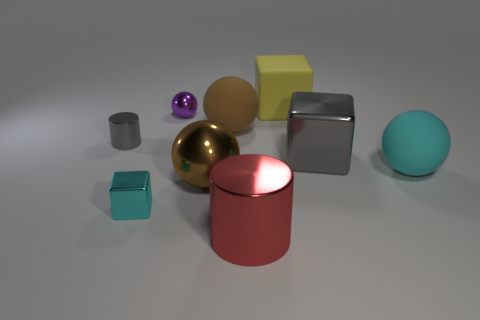Describe the lighting and shadows seen in the image. The image showcases a soft, diffused overhead lighting which creates gentle shadows beneath the objects. The direction of the light source appears to be from the top, as the shadows spread out below and to the sides of the objects. The light seems even, avoiding any harsh or dramatic contrasts. 